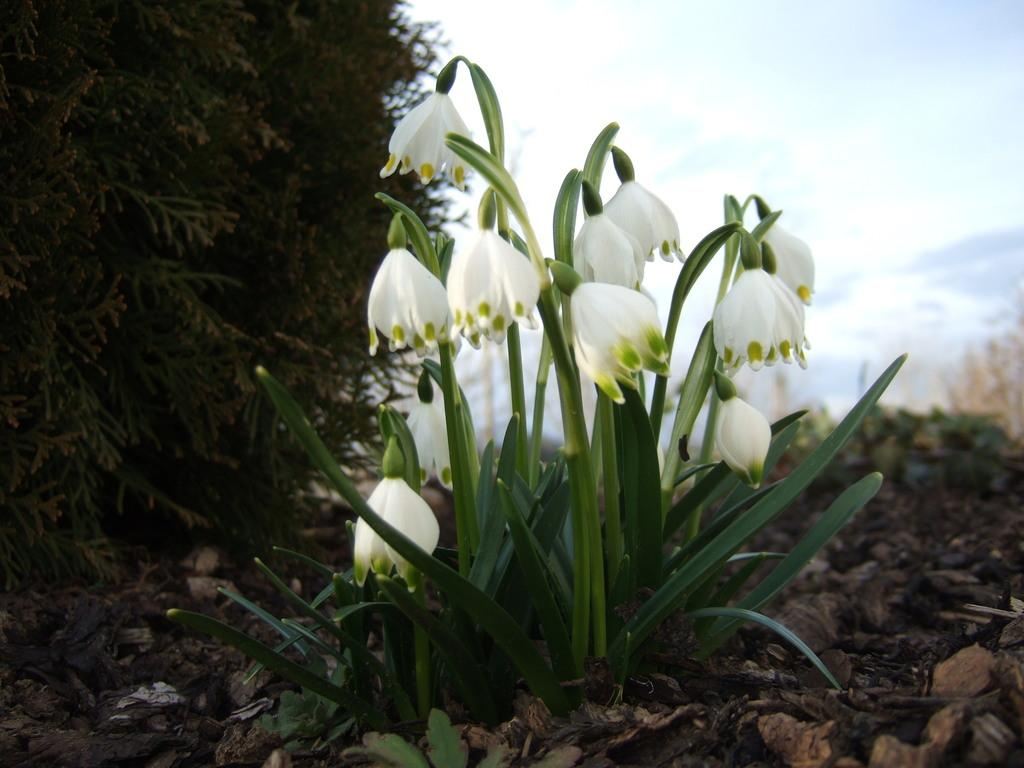What type of plant is featured in the image? There is a plant with flowers in the image. What other types of vegetation can be seen in the image? There is a tree and other plants in the image. What can be seen in the background of the image? The sky is visible in the image. Can you tell me how many faces are visible in the image? There are no faces present in the image; it features plants and a tree. What type of camp can be seen in the image? There is no camp present in the image. 